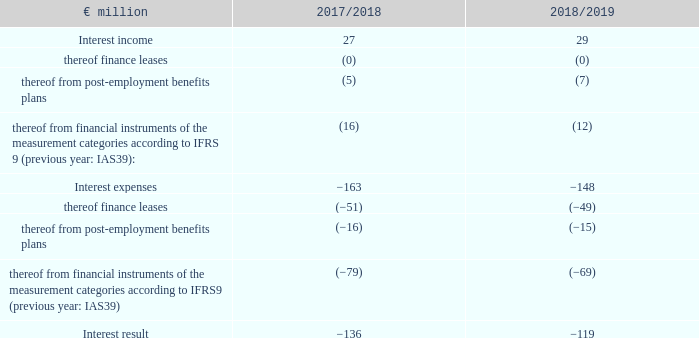9. Net interest income/interest expenses
The interest result can be broken down as follows:
Interest income and interest expenses from financial instruments are assigned to the measurement categories according to IFRS 9 on the basis of the underlying transactions.
The interest expenses included here (of the measurement categories in accordance with IFRS 9) primarily include interest expenses for issued bonds (including the Commercial Paper Programme) of €41 million (2017/18: €55 million) and for liabilities to banks of €19 million (2017/18: €12 million).
The decline in interest expenses was primarily the result of more favourable refinancing terms.
What are Interest income and interest expenses from financial instrument assigned to? Assigned to the measurement categories according to ifrs 9 on the basis of the underlying transactions. What led to the decline in interest expenses? Primarily the result of more favourable refinancing terms. What are the broad components in the table which are used to calculate the interest result? Interest income, interest expenses. In which year was the interest income larger? 29>27
Answer: 2018/2019. What was the change in interest income in 2018/2019 from 2017/2018?
Answer scale should be: million. 29-27
Answer: 2. What was the percentage change in interest income in 2018/2019 from 2017/2018?
Answer scale should be: percent. (29-27)/27
Answer: 7.41. 